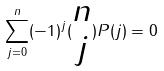Convert formula to latex. <formula><loc_0><loc_0><loc_500><loc_500>\sum _ { j = 0 } ^ { n } ( - 1 ) ^ { j } ( \begin{matrix} n \\ j \end{matrix} ) P ( j ) = 0</formula> 